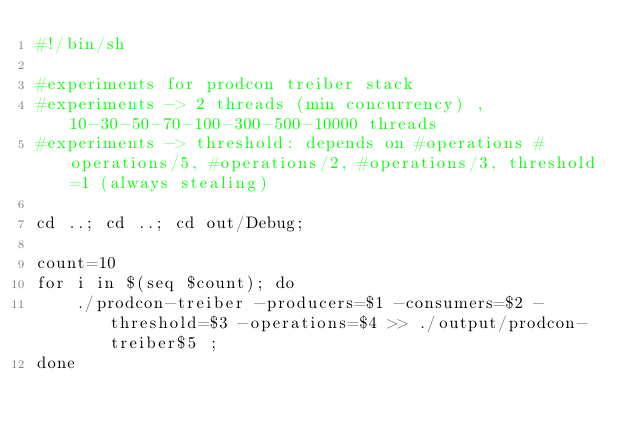<code> <loc_0><loc_0><loc_500><loc_500><_Bash_>#!/bin/sh

#experiments for prodcon treiber stack
#experiments -> 2 threads (min concurrency) , 10-30-50-70-100-300-500-10000 threads
#experiments -> threshold: depends on #operations #operations/5, #operations/2, #operations/3, threshold=1 (always stealing)

cd ..; cd ..; cd out/Debug;

count=10
for i in $(seq $count); do
    ./prodcon-treiber -producers=$1 -consumers=$2 -threshold=$3 -operations=$4 >> ./output/prodcon-treiber$5 ;
done


</code> 